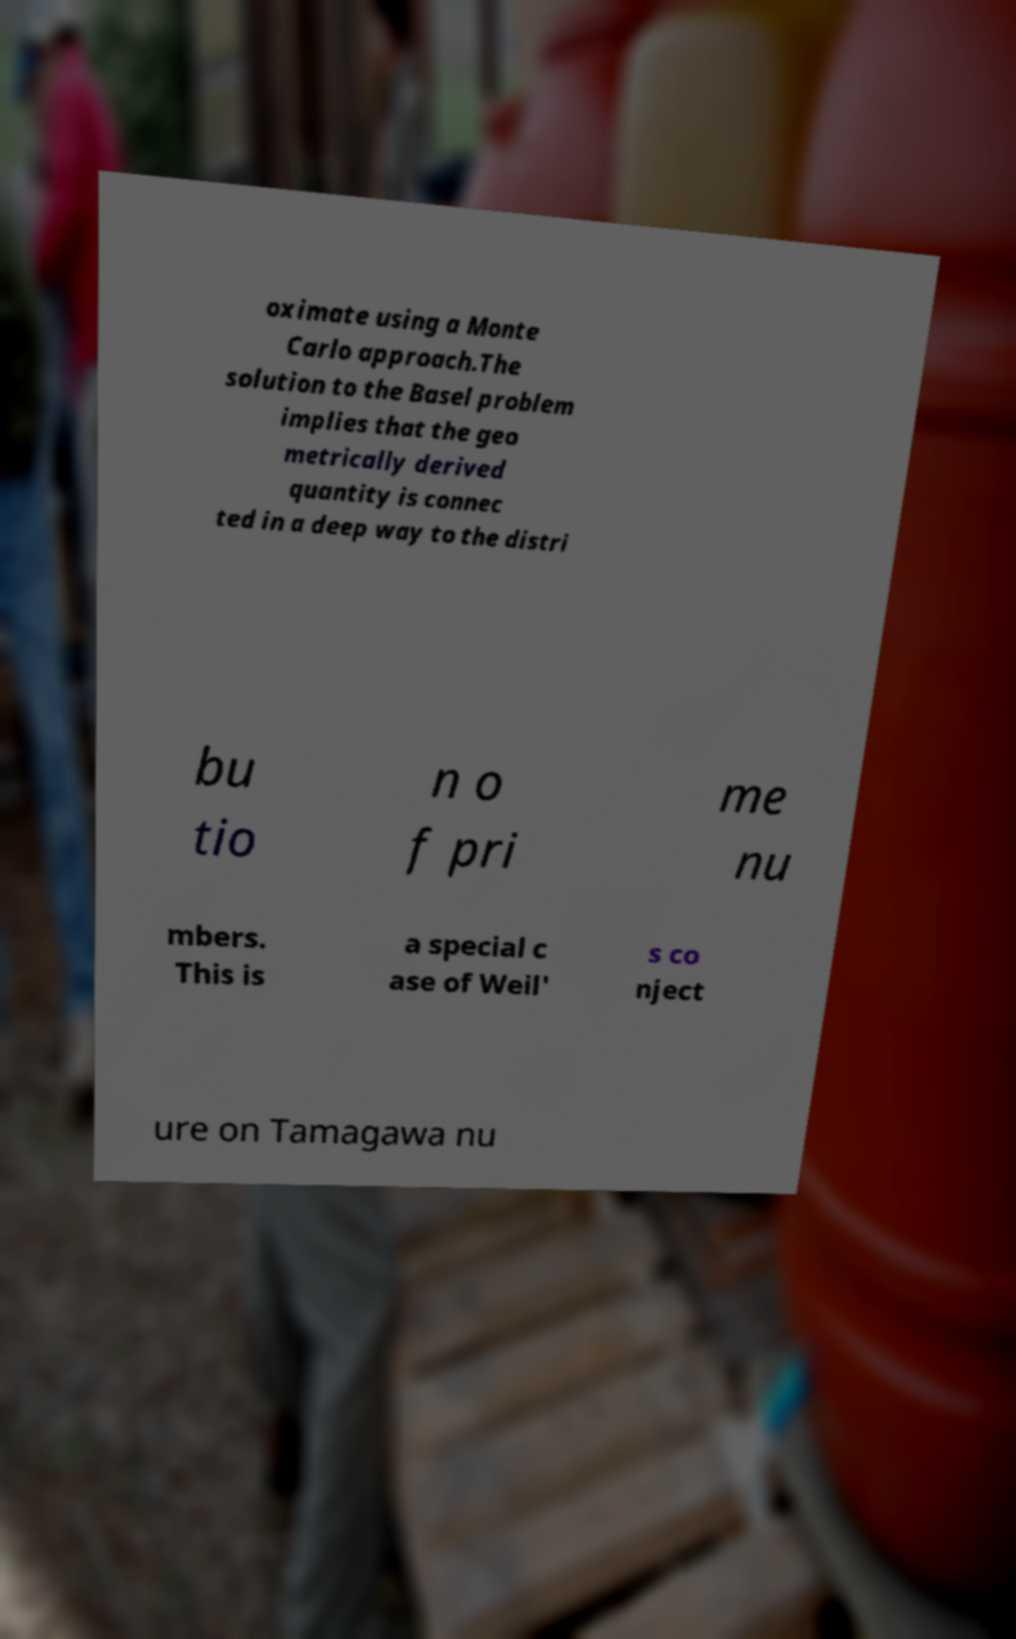Please identify and transcribe the text found in this image. oximate using a Monte Carlo approach.The solution to the Basel problem implies that the geo metrically derived quantity is connec ted in a deep way to the distri bu tio n o f pri me nu mbers. This is a special c ase of Weil' s co nject ure on Tamagawa nu 